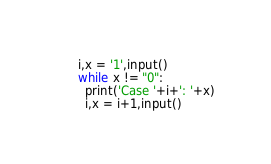Convert code to text. <code><loc_0><loc_0><loc_500><loc_500><_Python_>i,x = '1',input()
while x != "0":
  print('Case '+i+': '+x)
  i,x = i+1,input()
</code> 